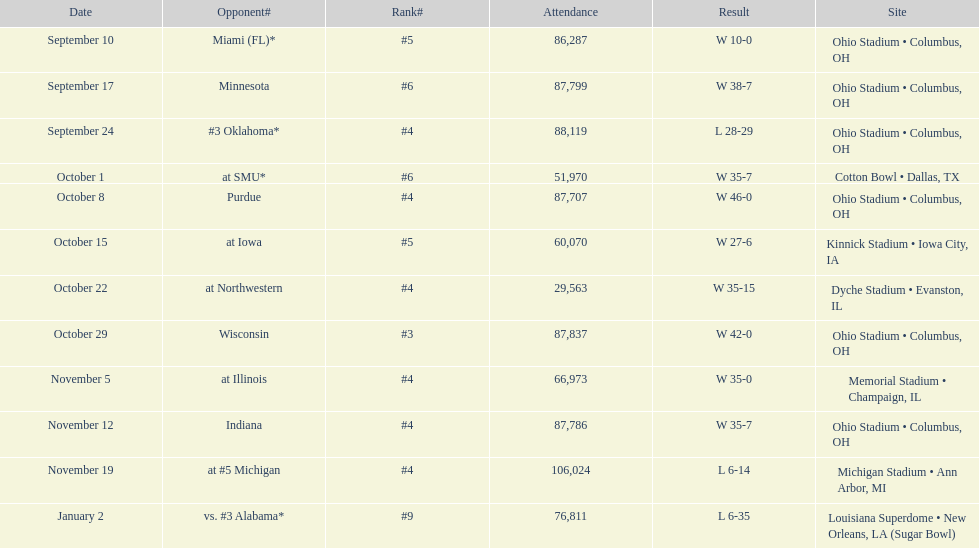In how many games were than more than 80,000 people attending 7. 